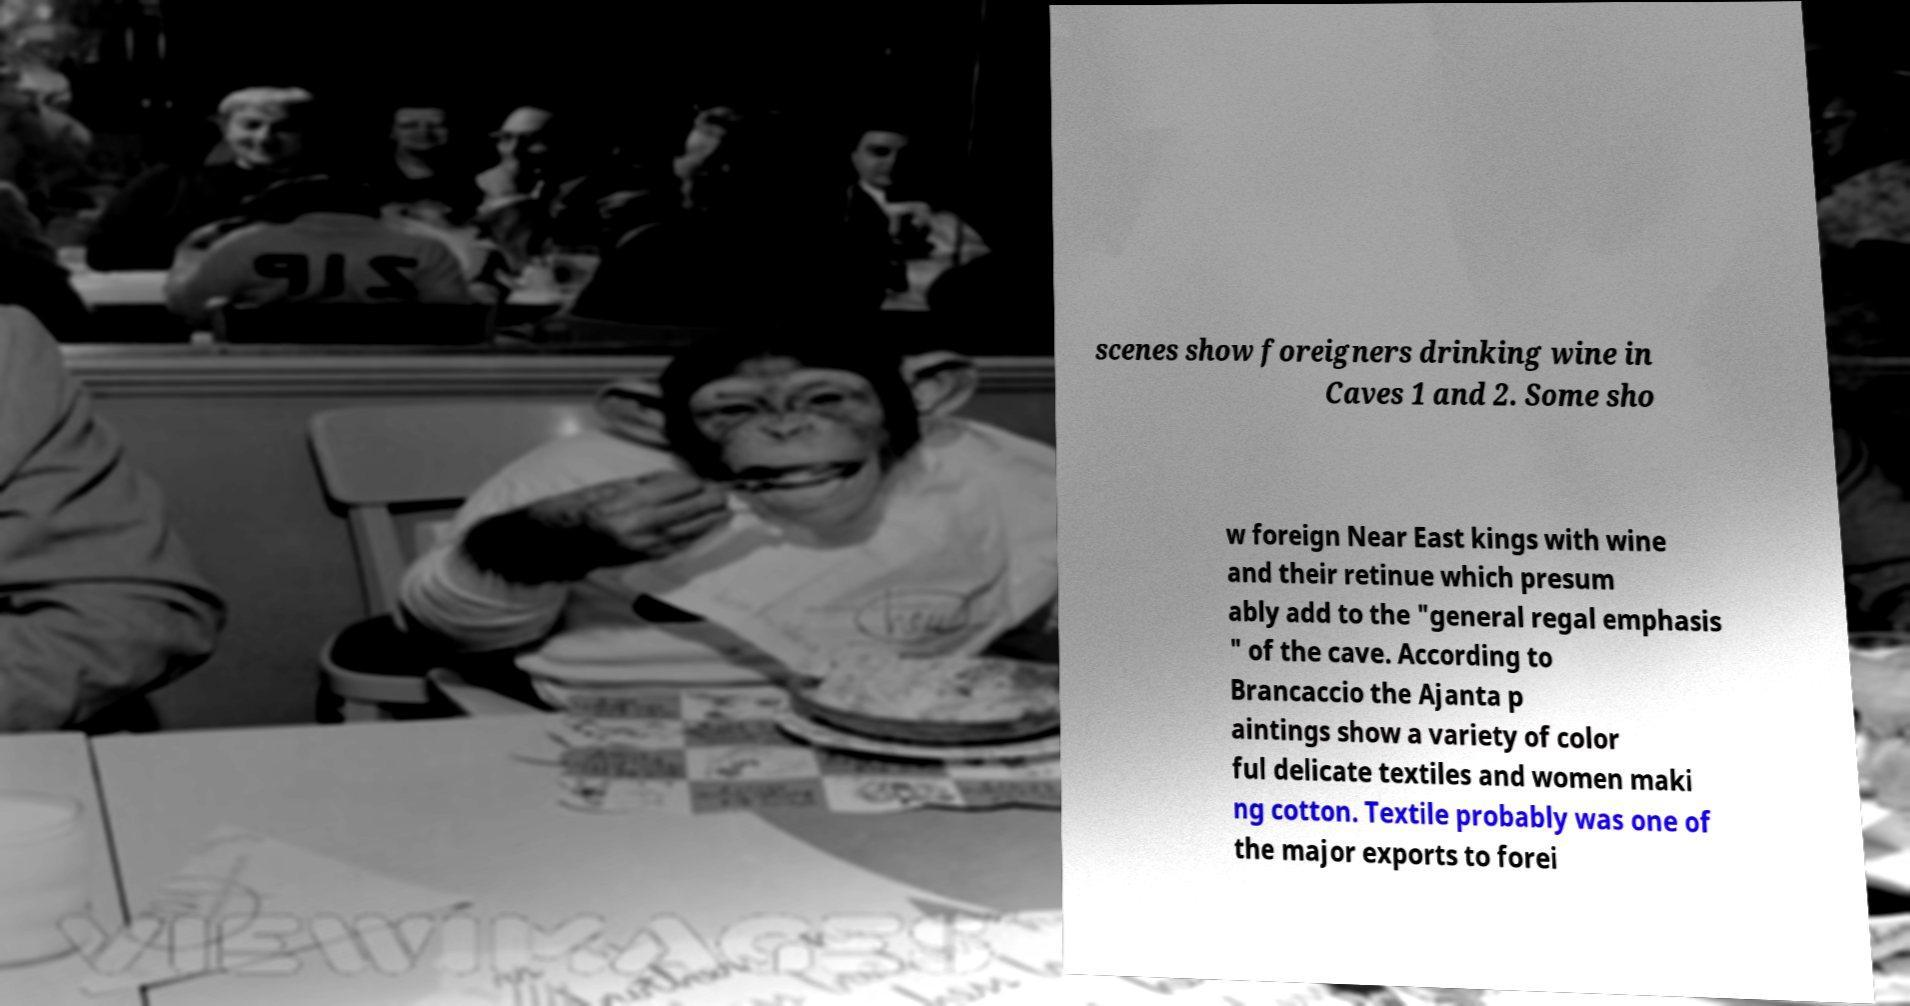Can you accurately transcribe the text from the provided image for me? scenes show foreigners drinking wine in Caves 1 and 2. Some sho w foreign Near East kings with wine and their retinue which presum ably add to the "general regal emphasis " of the cave. According to Brancaccio the Ajanta p aintings show a variety of color ful delicate textiles and women maki ng cotton. Textile probably was one of the major exports to forei 